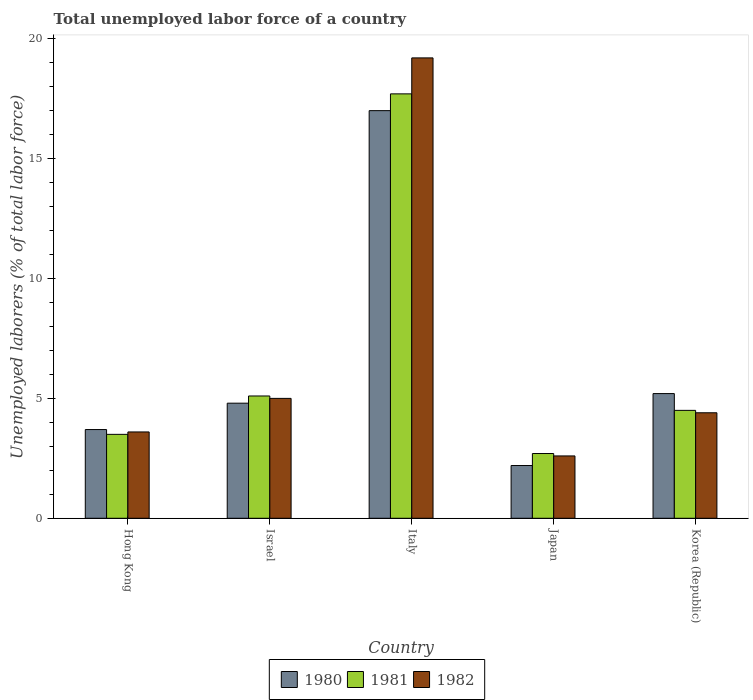How many different coloured bars are there?
Your response must be concise. 3. Are the number of bars per tick equal to the number of legend labels?
Your response must be concise. Yes. Across all countries, what is the maximum total unemployed labor force in 1981?
Your answer should be very brief. 17.7. Across all countries, what is the minimum total unemployed labor force in 1981?
Ensure brevity in your answer.  2.7. In which country was the total unemployed labor force in 1980 minimum?
Make the answer very short. Japan. What is the total total unemployed labor force in 1981 in the graph?
Provide a short and direct response. 33.5. What is the difference between the total unemployed labor force in 1982 in Japan and that in Korea (Republic)?
Provide a short and direct response. -1.8. What is the difference between the total unemployed labor force in 1981 in Korea (Republic) and the total unemployed labor force in 1980 in Israel?
Your answer should be compact. -0.3. What is the average total unemployed labor force in 1980 per country?
Make the answer very short. 6.58. What is the difference between the total unemployed labor force of/in 1982 and total unemployed labor force of/in 1980 in Italy?
Offer a very short reply. 2.2. In how many countries, is the total unemployed labor force in 1981 greater than 14 %?
Your response must be concise. 1. What is the ratio of the total unemployed labor force in 1981 in Israel to that in Italy?
Provide a succinct answer. 0.29. Is the total unemployed labor force in 1981 in Italy less than that in Korea (Republic)?
Ensure brevity in your answer.  No. Is the difference between the total unemployed labor force in 1982 in Hong Kong and Italy greater than the difference between the total unemployed labor force in 1980 in Hong Kong and Italy?
Make the answer very short. No. What is the difference between the highest and the second highest total unemployed labor force in 1981?
Provide a succinct answer. 13.2. What is the difference between the highest and the lowest total unemployed labor force in 1980?
Ensure brevity in your answer.  14.8. In how many countries, is the total unemployed labor force in 1981 greater than the average total unemployed labor force in 1981 taken over all countries?
Offer a very short reply. 1. What does the 1st bar from the right in Japan represents?
Offer a very short reply. 1982. How many bars are there?
Make the answer very short. 15. How many countries are there in the graph?
Offer a very short reply. 5. What is the difference between two consecutive major ticks on the Y-axis?
Provide a succinct answer. 5. Are the values on the major ticks of Y-axis written in scientific E-notation?
Make the answer very short. No. Does the graph contain grids?
Provide a succinct answer. No. Where does the legend appear in the graph?
Offer a terse response. Bottom center. How are the legend labels stacked?
Ensure brevity in your answer.  Horizontal. What is the title of the graph?
Offer a very short reply. Total unemployed labor force of a country. Does "2004" appear as one of the legend labels in the graph?
Your response must be concise. No. What is the label or title of the X-axis?
Make the answer very short. Country. What is the label or title of the Y-axis?
Give a very brief answer. Unemployed laborers (% of total labor force). What is the Unemployed laborers (% of total labor force) in 1980 in Hong Kong?
Keep it short and to the point. 3.7. What is the Unemployed laborers (% of total labor force) of 1982 in Hong Kong?
Ensure brevity in your answer.  3.6. What is the Unemployed laborers (% of total labor force) in 1980 in Israel?
Your answer should be compact. 4.8. What is the Unemployed laborers (% of total labor force) of 1981 in Israel?
Provide a succinct answer. 5.1. What is the Unemployed laborers (% of total labor force) of 1981 in Italy?
Your response must be concise. 17.7. What is the Unemployed laborers (% of total labor force) of 1982 in Italy?
Offer a very short reply. 19.2. What is the Unemployed laborers (% of total labor force) in 1980 in Japan?
Your answer should be very brief. 2.2. What is the Unemployed laborers (% of total labor force) in 1981 in Japan?
Provide a succinct answer. 2.7. What is the Unemployed laborers (% of total labor force) in 1982 in Japan?
Ensure brevity in your answer.  2.6. What is the Unemployed laborers (% of total labor force) of 1980 in Korea (Republic)?
Offer a terse response. 5.2. What is the Unemployed laborers (% of total labor force) in 1982 in Korea (Republic)?
Your answer should be very brief. 4.4. Across all countries, what is the maximum Unemployed laborers (% of total labor force) in 1980?
Ensure brevity in your answer.  17. Across all countries, what is the maximum Unemployed laborers (% of total labor force) of 1981?
Provide a short and direct response. 17.7. Across all countries, what is the maximum Unemployed laborers (% of total labor force) of 1982?
Offer a terse response. 19.2. Across all countries, what is the minimum Unemployed laborers (% of total labor force) in 1980?
Make the answer very short. 2.2. Across all countries, what is the minimum Unemployed laborers (% of total labor force) in 1981?
Keep it short and to the point. 2.7. Across all countries, what is the minimum Unemployed laborers (% of total labor force) in 1982?
Offer a terse response. 2.6. What is the total Unemployed laborers (% of total labor force) in 1980 in the graph?
Provide a succinct answer. 32.9. What is the total Unemployed laborers (% of total labor force) of 1981 in the graph?
Your response must be concise. 33.5. What is the total Unemployed laborers (% of total labor force) of 1982 in the graph?
Your answer should be very brief. 34.8. What is the difference between the Unemployed laborers (% of total labor force) of 1980 in Hong Kong and that in Israel?
Provide a short and direct response. -1.1. What is the difference between the Unemployed laborers (% of total labor force) of 1981 in Hong Kong and that in Israel?
Your answer should be very brief. -1.6. What is the difference between the Unemployed laborers (% of total labor force) in 1981 in Hong Kong and that in Italy?
Provide a short and direct response. -14.2. What is the difference between the Unemployed laborers (% of total labor force) of 1982 in Hong Kong and that in Italy?
Offer a very short reply. -15.6. What is the difference between the Unemployed laborers (% of total labor force) of 1980 in Hong Kong and that in Japan?
Make the answer very short. 1.5. What is the difference between the Unemployed laborers (% of total labor force) of 1980 in Hong Kong and that in Korea (Republic)?
Ensure brevity in your answer.  -1.5. What is the difference between the Unemployed laborers (% of total labor force) in 1982 in Hong Kong and that in Korea (Republic)?
Offer a very short reply. -0.8. What is the difference between the Unemployed laborers (% of total labor force) in 1980 in Israel and that in Italy?
Provide a short and direct response. -12.2. What is the difference between the Unemployed laborers (% of total labor force) of 1981 in Israel and that in Italy?
Offer a terse response. -12.6. What is the difference between the Unemployed laborers (% of total labor force) in 1982 in Israel and that in Italy?
Give a very brief answer. -14.2. What is the difference between the Unemployed laborers (% of total labor force) in 1980 in Israel and that in Korea (Republic)?
Your answer should be very brief. -0.4. What is the difference between the Unemployed laborers (% of total labor force) of 1981 in Israel and that in Korea (Republic)?
Ensure brevity in your answer.  0.6. What is the difference between the Unemployed laborers (% of total labor force) of 1980 in Italy and that in Japan?
Offer a very short reply. 14.8. What is the difference between the Unemployed laborers (% of total labor force) in 1981 in Italy and that in Japan?
Ensure brevity in your answer.  15. What is the difference between the Unemployed laborers (% of total labor force) of 1980 in Italy and that in Korea (Republic)?
Keep it short and to the point. 11.8. What is the difference between the Unemployed laborers (% of total labor force) in 1982 in Italy and that in Korea (Republic)?
Give a very brief answer. 14.8. What is the difference between the Unemployed laborers (% of total labor force) in 1981 in Japan and that in Korea (Republic)?
Your answer should be compact. -1.8. What is the difference between the Unemployed laborers (% of total labor force) in 1981 in Hong Kong and the Unemployed laborers (% of total labor force) in 1982 in Israel?
Give a very brief answer. -1.5. What is the difference between the Unemployed laborers (% of total labor force) in 1980 in Hong Kong and the Unemployed laborers (% of total labor force) in 1981 in Italy?
Offer a very short reply. -14. What is the difference between the Unemployed laborers (% of total labor force) of 1980 in Hong Kong and the Unemployed laborers (% of total labor force) of 1982 in Italy?
Provide a short and direct response. -15.5. What is the difference between the Unemployed laborers (% of total labor force) of 1981 in Hong Kong and the Unemployed laborers (% of total labor force) of 1982 in Italy?
Your answer should be very brief. -15.7. What is the difference between the Unemployed laborers (% of total labor force) in 1980 in Hong Kong and the Unemployed laborers (% of total labor force) in 1982 in Korea (Republic)?
Make the answer very short. -0.7. What is the difference between the Unemployed laborers (% of total labor force) of 1981 in Hong Kong and the Unemployed laborers (% of total labor force) of 1982 in Korea (Republic)?
Give a very brief answer. -0.9. What is the difference between the Unemployed laborers (% of total labor force) of 1980 in Israel and the Unemployed laborers (% of total labor force) of 1981 in Italy?
Your response must be concise. -12.9. What is the difference between the Unemployed laborers (% of total labor force) of 1980 in Israel and the Unemployed laborers (% of total labor force) of 1982 in Italy?
Your answer should be very brief. -14.4. What is the difference between the Unemployed laborers (% of total labor force) in 1981 in Israel and the Unemployed laborers (% of total labor force) in 1982 in Italy?
Your answer should be very brief. -14.1. What is the difference between the Unemployed laborers (% of total labor force) of 1980 in Israel and the Unemployed laborers (% of total labor force) of 1981 in Japan?
Offer a terse response. 2.1. What is the difference between the Unemployed laborers (% of total labor force) in 1980 in Israel and the Unemployed laborers (% of total labor force) in 1982 in Japan?
Your answer should be very brief. 2.2. What is the difference between the Unemployed laborers (% of total labor force) in 1980 in Israel and the Unemployed laborers (% of total labor force) in 1981 in Korea (Republic)?
Give a very brief answer. 0.3. What is the difference between the Unemployed laborers (% of total labor force) of 1980 in Italy and the Unemployed laborers (% of total labor force) of 1982 in Japan?
Provide a succinct answer. 14.4. What is the difference between the Unemployed laborers (% of total labor force) in 1980 in Italy and the Unemployed laborers (% of total labor force) in 1981 in Korea (Republic)?
Make the answer very short. 12.5. What is the difference between the Unemployed laborers (% of total labor force) in 1980 in Italy and the Unemployed laborers (% of total labor force) in 1982 in Korea (Republic)?
Make the answer very short. 12.6. What is the difference between the Unemployed laborers (% of total labor force) of 1980 in Japan and the Unemployed laborers (% of total labor force) of 1982 in Korea (Republic)?
Give a very brief answer. -2.2. What is the difference between the Unemployed laborers (% of total labor force) in 1981 in Japan and the Unemployed laborers (% of total labor force) in 1982 in Korea (Republic)?
Keep it short and to the point. -1.7. What is the average Unemployed laborers (% of total labor force) of 1980 per country?
Your answer should be compact. 6.58. What is the average Unemployed laborers (% of total labor force) in 1981 per country?
Make the answer very short. 6.7. What is the average Unemployed laborers (% of total labor force) in 1982 per country?
Offer a terse response. 6.96. What is the difference between the Unemployed laborers (% of total labor force) in 1980 and Unemployed laborers (% of total labor force) in 1981 in Israel?
Give a very brief answer. -0.3. What is the difference between the Unemployed laborers (% of total labor force) in 1980 and Unemployed laborers (% of total labor force) in 1982 in Israel?
Your answer should be very brief. -0.2. What is the difference between the Unemployed laborers (% of total labor force) in 1981 and Unemployed laborers (% of total labor force) in 1982 in Israel?
Your response must be concise. 0.1. What is the difference between the Unemployed laborers (% of total labor force) of 1980 and Unemployed laborers (% of total labor force) of 1982 in Italy?
Provide a short and direct response. -2.2. What is the difference between the Unemployed laborers (% of total labor force) of 1980 and Unemployed laborers (% of total labor force) of 1982 in Japan?
Your answer should be compact. -0.4. What is the difference between the Unemployed laborers (% of total labor force) of 1980 and Unemployed laborers (% of total labor force) of 1981 in Korea (Republic)?
Ensure brevity in your answer.  0.7. What is the ratio of the Unemployed laborers (% of total labor force) of 1980 in Hong Kong to that in Israel?
Your response must be concise. 0.77. What is the ratio of the Unemployed laborers (% of total labor force) in 1981 in Hong Kong to that in Israel?
Your answer should be very brief. 0.69. What is the ratio of the Unemployed laborers (% of total labor force) in 1982 in Hong Kong to that in Israel?
Give a very brief answer. 0.72. What is the ratio of the Unemployed laborers (% of total labor force) in 1980 in Hong Kong to that in Italy?
Provide a short and direct response. 0.22. What is the ratio of the Unemployed laborers (% of total labor force) of 1981 in Hong Kong to that in Italy?
Your response must be concise. 0.2. What is the ratio of the Unemployed laborers (% of total labor force) in 1982 in Hong Kong to that in Italy?
Your response must be concise. 0.19. What is the ratio of the Unemployed laborers (% of total labor force) in 1980 in Hong Kong to that in Japan?
Offer a very short reply. 1.68. What is the ratio of the Unemployed laborers (% of total labor force) of 1981 in Hong Kong to that in Japan?
Give a very brief answer. 1.3. What is the ratio of the Unemployed laborers (% of total labor force) in 1982 in Hong Kong to that in Japan?
Ensure brevity in your answer.  1.38. What is the ratio of the Unemployed laborers (% of total labor force) of 1980 in Hong Kong to that in Korea (Republic)?
Give a very brief answer. 0.71. What is the ratio of the Unemployed laborers (% of total labor force) in 1982 in Hong Kong to that in Korea (Republic)?
Ensure brevity in your answer.  0.82. What is the ratio of the Unemployed laborers (% of total labor force) of 1980 in Israel to that in Italy?
Give a very brief answer. 0.28. What is the ratio of the Unemployed laborers (% of total labor force) of 1981 in Israel to that in Italy?
Give a very brief answer. 0.29. What is the ratio of the Unemployed laborers (% of total labor force) in 1982 in Israel to that in Italy?
Ensure brevity in your answer.  0.26. What is the ratio of the Unemployed laborers (% of total labor force) in 1980 in Israel to that in Japan?
Your answer should be compact. 2.18. What is the ratio of the Unemployed laborers (% of total labor force) of 1981 in Israel to that in Japan?
Your answer should be very brief. 1.89. What is the ratio of the Unemployed laborers (% of total labor force) of 1982 in Israel to that in Japan?
Provide a short and direct response. 1.92. What is the ratio of the Unemployed laborers (% of total labor force) of 1981 in Israel to that in Korea (Republic)?
Your answer should be compact. 1.13. What is the ratio of the Unemployed laborers (% of total labor force) of 1982 in Israel to that in Korea (Republic)?
Provide a succinct answer. 1.14. What is the ratio of the Unemployed laborers (% of total labor force) in 1980 in Italy to that in Japan?
Offer a terse response. 7.73. What is the ratio of the Unemployed laborers (% of total labor force) of 1981 in Italy to that in Japan?
Offer a terse response. 6.56. What is the ratio of the Unemployed laborers (% of total labor force) in 1982 in Italy to that in Japan?
Your response must be concise. 7.38. What is the ratio of the Unemployed laborers (% of total labor force) of 1980 in Italy to that in Korea (Republic)?
Make the answer very short. 3.27. What is the ratio of the Unemployed laborers (% of total labor force) in 1981 in Italy to that in Korea (Republic)?
Make the answer very short. 3.93. What is the ratio of the Unemployed laborers (% of total labor force) of 1982 in Italy to that in Korea (Republic)?
Make the answer very short. 4.36. What is the ratio of the Unemployed laborers (% of total labor force) of 1980 in Japan to that in Korea (Republic)?
Your answer should be very brief. 0.42. What is the ratio of the Unemployed laborers (% of total labor force) of 1981 in Japan to that in Korea (Republic)?
Ensure brevity in your answer.  0.6. What is the ratio of the Unemployed laborers (% of total labor force) of 1982 in Japan to that in Korea (Republic)?
Offer a very short reply. 0.59. What is the difference between the highest and the lowest Unemployed laborers (% of total labor force) of 1981?
Your answer should be compact. 15. What is the difference between the highest and the lowest Unemployed laborers (% of total labor force) in 1982?
Your answer should be compact. 16.6. 